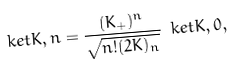<formula> <loc_0><loc_0><loc_500><loc_500>\ k e t { K , n } = \frac { ( K _ { + } ) ^ { n } } { \sqrt { n ! ( 2 K ) _ { n } } } \ k e t { K , 0 } ,</formula> 